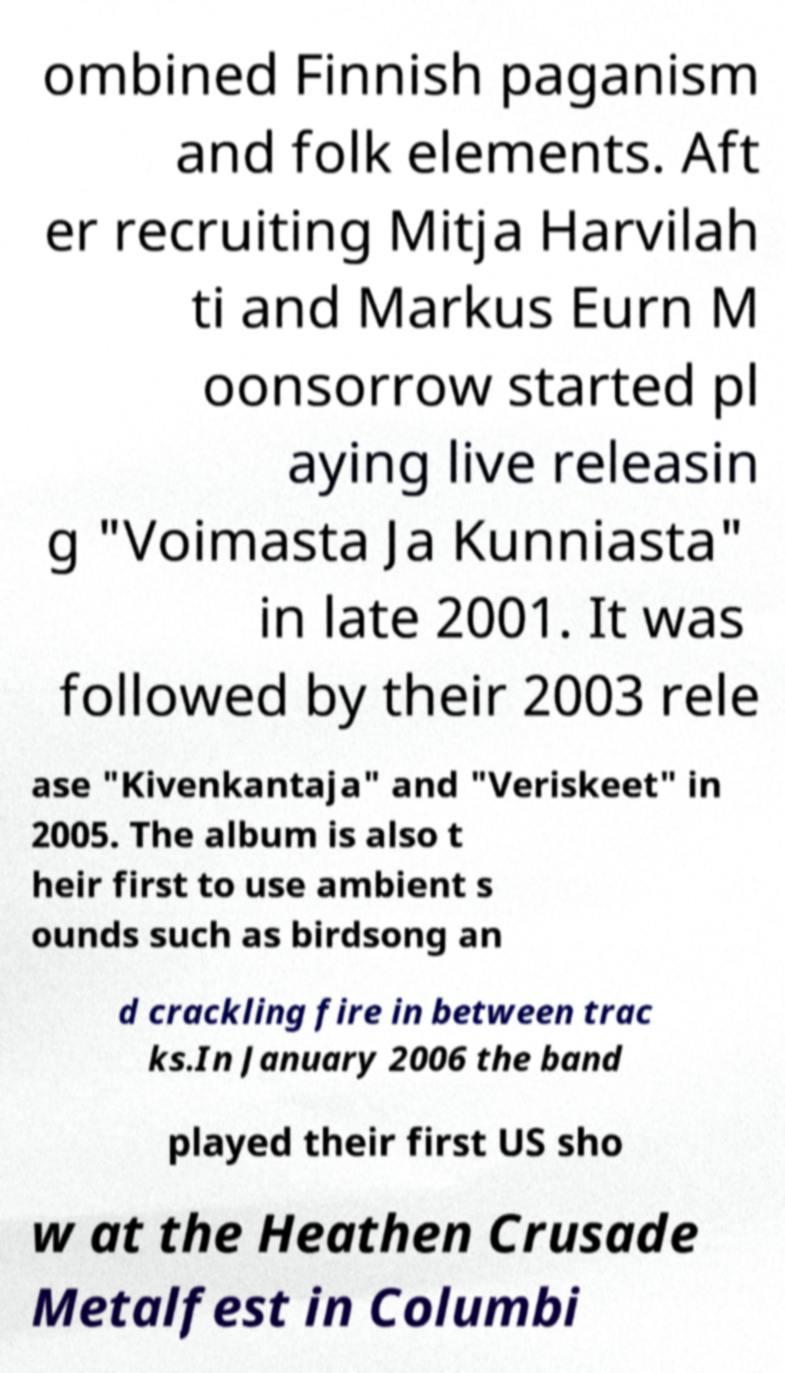Could you assist in decoding the text presented in this image and type it out clearly? ombined Finnish paganism and folk elements. Aft er recruiting Mitja Harvilah ti and Markus Eurn M oonsorrow started pl aying live releasin g "Voimasta Ja Kunniasta" in late 2001. It was followed by their 2003 rele ase "Kivenkantaja" and "Veriskeet" in 2005. The album is also t heir first to use ambient s ounds such as birdsong an d crackling fire in between trac ks.In January 2006 the band played their first US sho w at the Heathen Crusade Metalfest in Columbi 